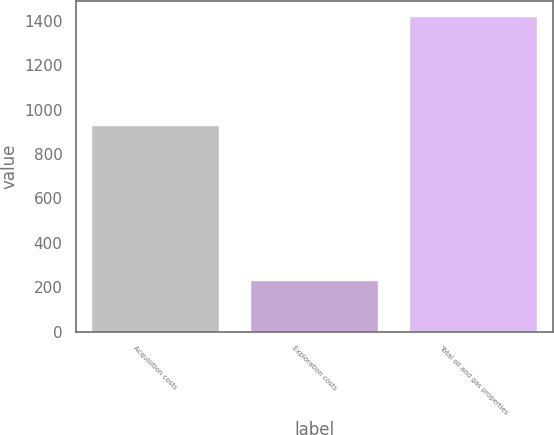Convert chart to OTSL. <chart><loc_0><loc_0><loc_500><loc_500><bar_chart><fcel>Acquisition costs<fcel>Exploration costs<fcel>Total oil and gas properties<nl><fcel>928<fcel>228<fcel>1418<nl></chart> 